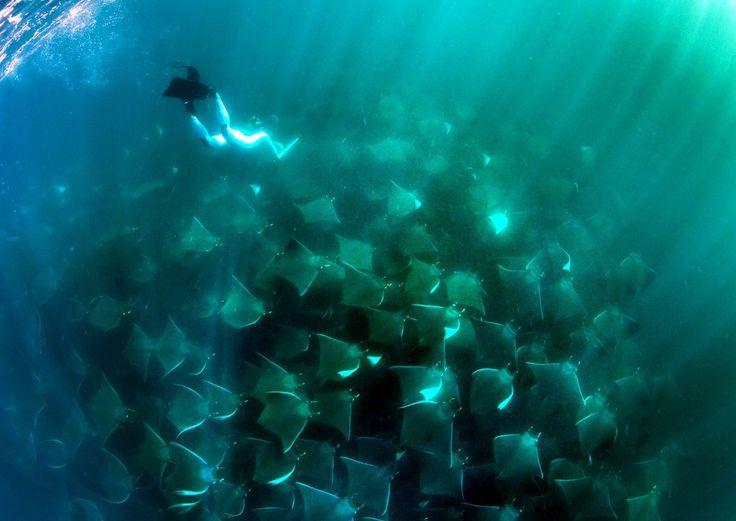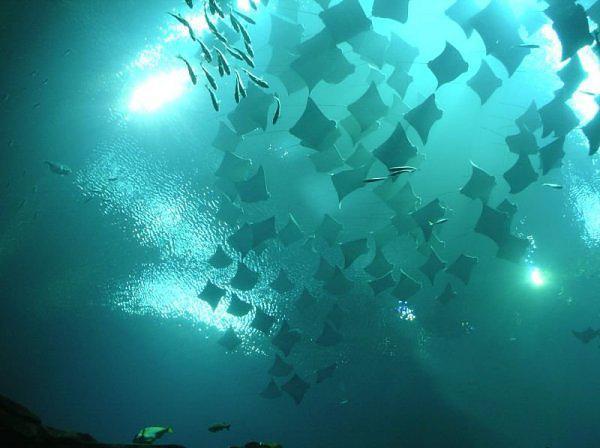The first image is the image on the left, the second image is the image on the right. Evaluate the accuracy of this statement regarding the images: "There are at most 4 sting rays in one of the images.". Is it true? Answer yes or no. No. The first image is the image on the left, the second image is the image on the right. Evaluate the accuracy of this statement regarding the images: "At least one image contains no more than three stingray.". Is it true? Answer yes or no. No. 